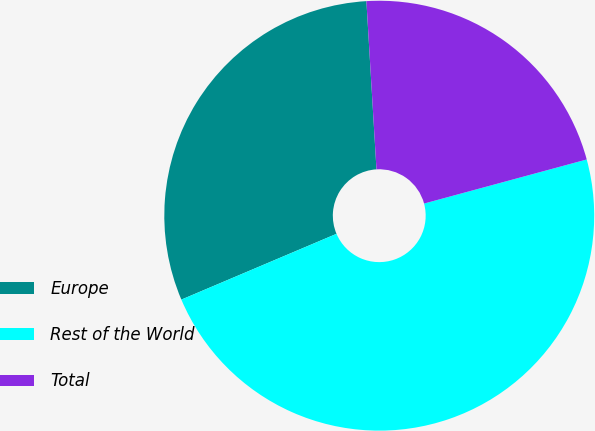<chart> <loc_0><loc_0><loc_500><loc_500><pie_chart><fcel>Europe<fcel>Rest of the World<fcel>Total<nl><fcel>30.43%<fcel>47.83%<fcel>21.74%<nl></chart> 